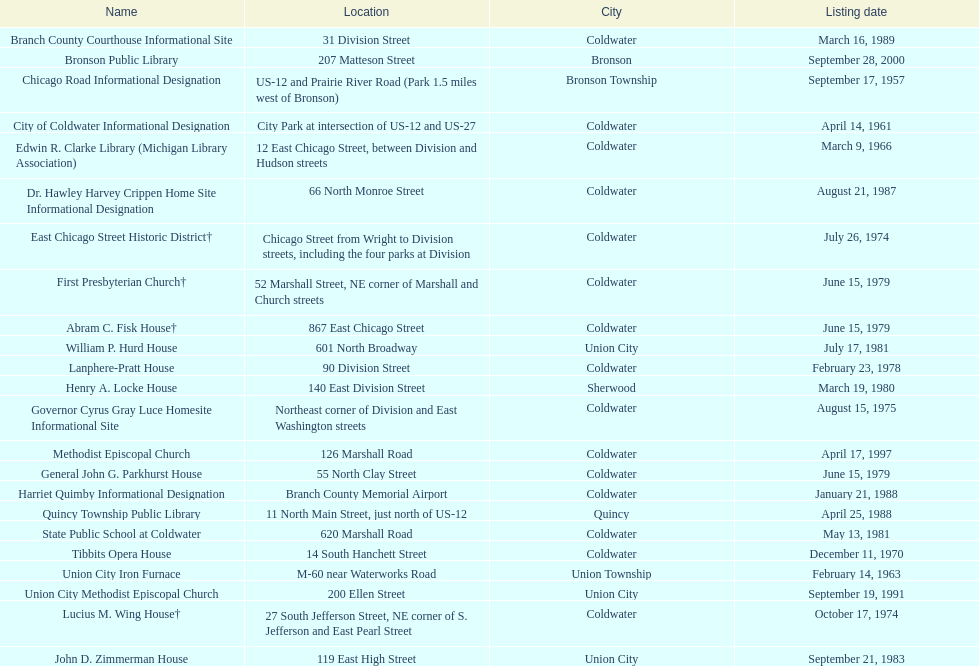Which location was mentioned first, the state public school or the edwin r. clarke library? Edwin R. Clarke Library. Would you mind parsing the complete table? {'header': ['Name', 'Location', 'City', 'Listing date'], 'rows': [['Branch County Courthouse Informational Site', '31 Division Street', 'Coldwater', 'March 16, 1989'], ['Bronson Public Library', '207 Matteson Street', 'Bronson', 'September 28, 2000'], ['Chicago Road Informational Designation', 'US-12 and Prairie River Road (Park 1.5 miles west of Bronson)', 'Bronson Township', 'September 17, 1957'], ['City of Coldwater Informational Designation', 'City Park at intersection of US-12 and US-27', 'Coldwater', 'April 14, 1961'], ['Edwin R. Clarke Library (Michigan Library Association)', '12 East Chicago Street, between Division and Hudson streets', 'Coldwater', 'March 9, 1966'], ['Dr. Hawley Harvey Crippen Home Site Informational Designation', '66 North Monroe Street', 'Coldwater', 'August 21, 1987'], ['East Chicago Street Historic District†', 'Chicago Street from Wright to Division streets, including the four parks at Division', 'Coldwater', 'July 26, 1974'], ['First Presbyterian Church†', '52 Marshall Street, NE corner of Marshall and Church streets', 'Coldwater', 'June 15, 1979'], ['Abram C. Fisk House†', '867 East Chicago Street', 'Coldwater', 'June 15, 1979'], ['William P. Hurd House', '601 North Broadway', 'Union City', 'July 17, 1981'], ['Lanphere-Pratt House', '90 Division Street', 'Coldwater', 'February 23, 1978'], ['Henry A. Locke House', '140 East Division Street', 'Sherwood', 'March 19, 1980'], ['Governor Cyrus Gray Luce Homesite Informational Site', 'Northeast corner of Division and East Washington streets', 'Coldwater', 'August 15, 1975'], ['Methodist Episcopal Church', '126 Marshall Road', 'Coldwater', 'April 17, 1997'], ['General John G. Parkhurst House', '55 North Clay Street', 'Coldwater', 'June 15, 1979'], ['Harriet Quimby Informational Designation', 'Branch County Memorial Airport', 'Coldwater', 'January 21, 1988'], ['Quincy Township Public Library', '11 North Main Street, just north of US-12', 'Quincy', 'April 25, 1988'], ['State Public School at Coldwater', '620 Marshall Road', 'Coldwater', 'May 13, 1981'], ['Tibbits Opera House', '14 South Hanchett Street', 'Coldwater', 'December 11, 1970'], ['Union City Iron Furnace', 'M-60 near Waterworks Road', 'Union Township', 'February 14, 1963'], ['Union City Methodist Episcopal Church', '200 Ellen Street', 'Union City', 'September 19, 1991'], ['Lucius M. Wing House†', '27 South Jefferson Street, NE corner of S. Jefferson and East Pearl Street', 'Coldwater', 'October 17, 1974'], ['John D. Zimmerman House', '119 East High Street', 'Union City', 'September 21, 1983']]} 